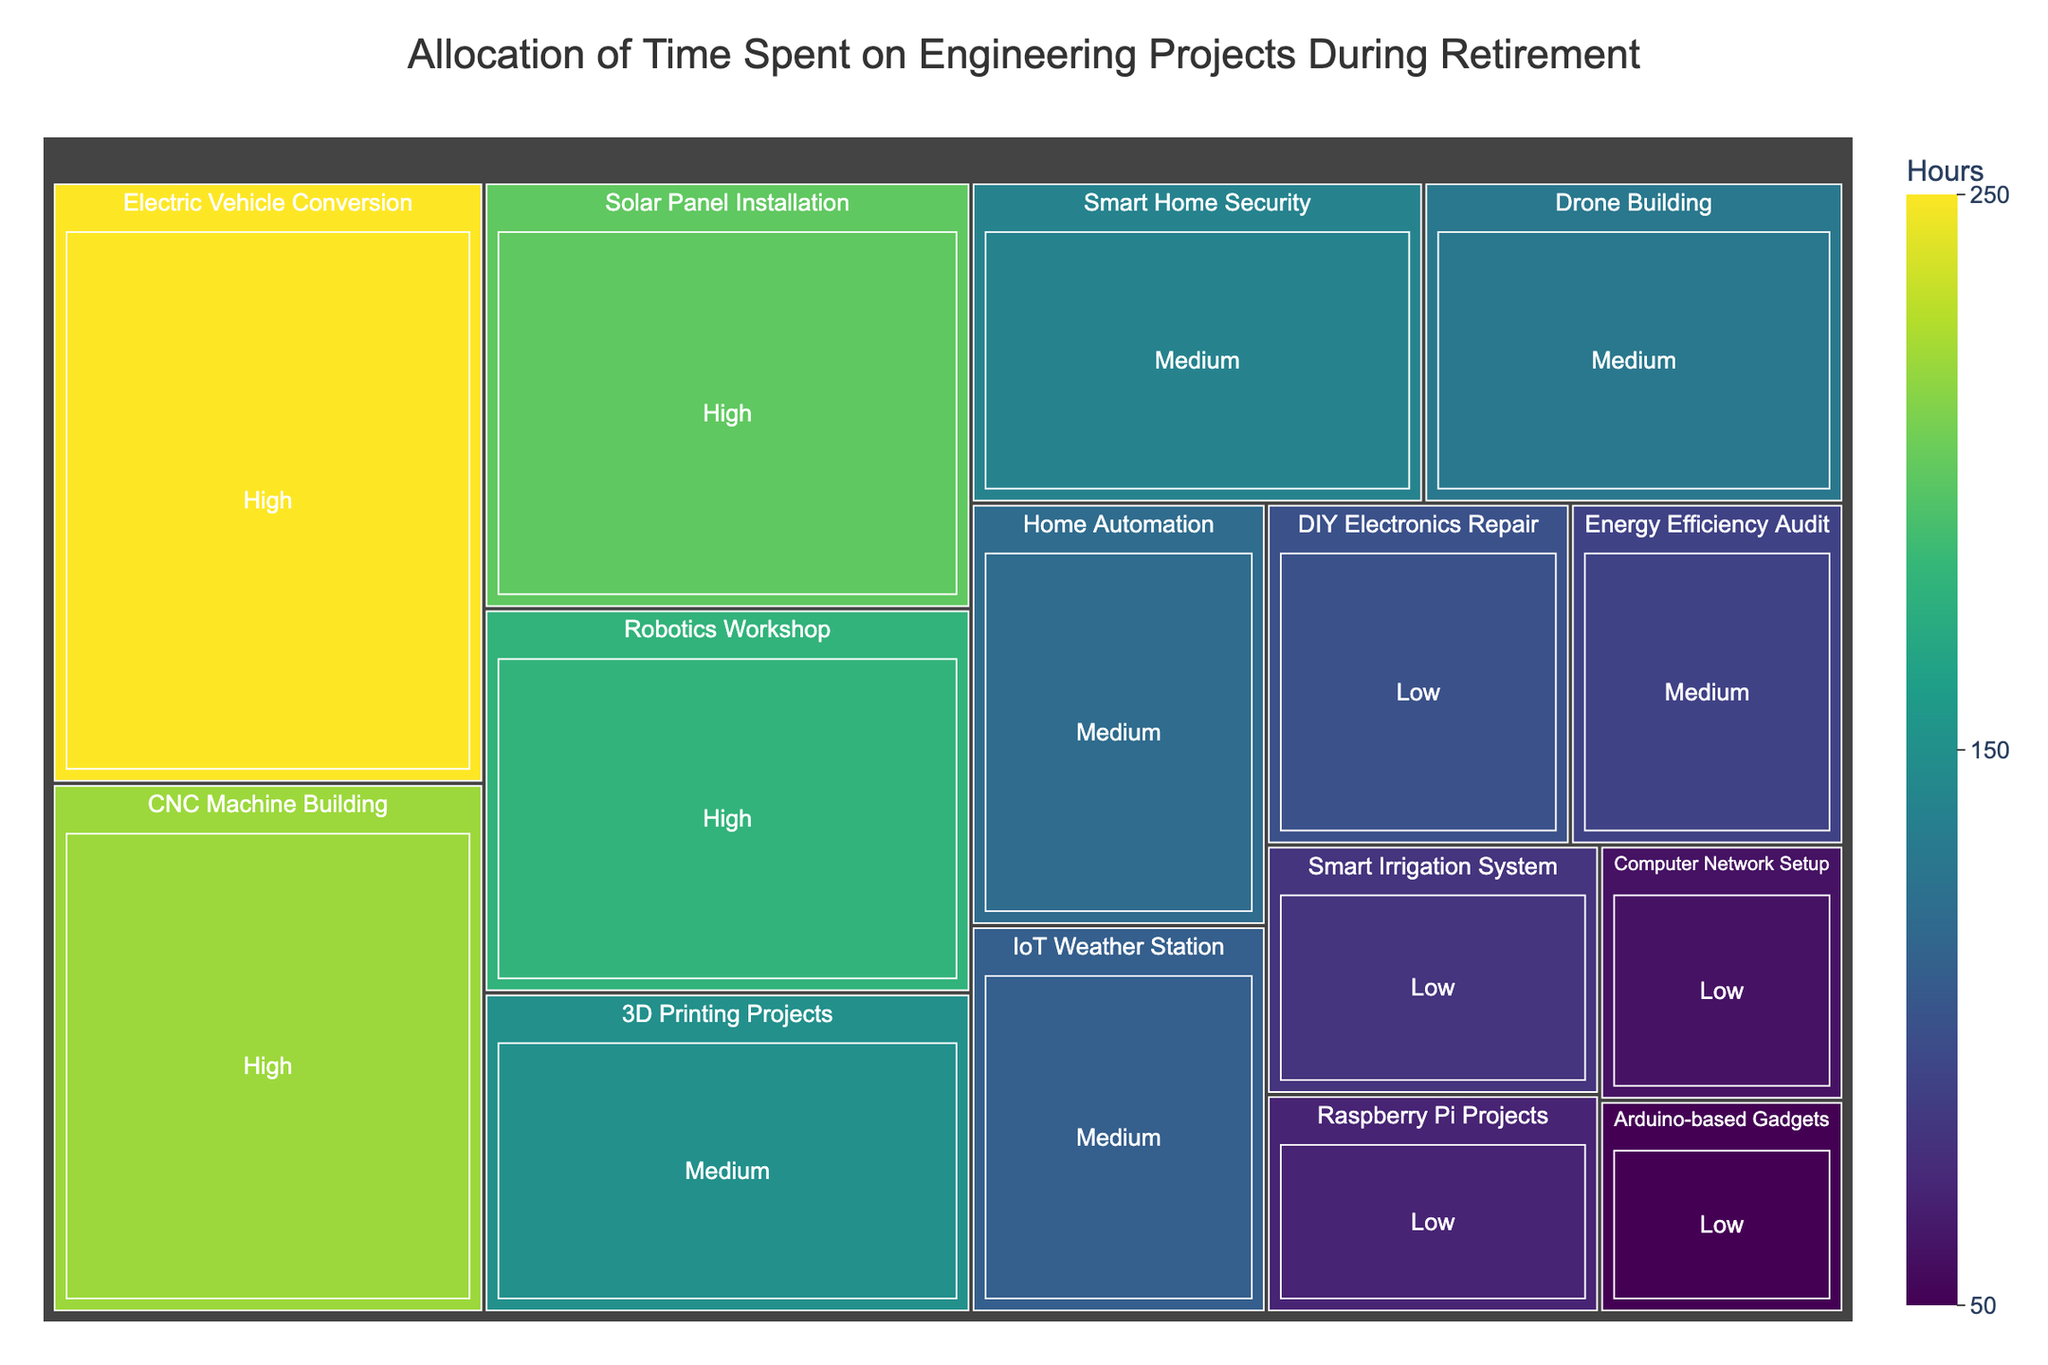What's the title of the figure? The title is placed at the top of the treemap and represents the overall theme of the figure.
Answer: Allocation of Time Spent on Engineering Projects During Retirement How many hours were spent on high complexity projects? To determine the total hours spent on high complexity projects, sum up the hours of all high complexity projects: Solar Panel Installation (200) + Robotics Workshop (180) + Electric Vehicle Conversion (250) + CNC Machine Building (220). 200 + 180 + 250 + 220 = 850
Answer: 850 Which project type had the highest number of hours? Look for the largest segment in the treemap and check its corresponding project type by comparing the hours. Electric Vehicle Conversion has the highest hours at 250.
Answer: Electric Vehicle Conversion What is the difference in hours between the project with the most time spent and the project with the least time spent? Identify the projects with the maximum and minimum hours from the treemap. The project with the most time is Electric Vehicle Conversion (250 hours) and the one with the least time is Arduino-based Gadgets (50 hours). The difference is 250 - 50 = 200 hours.
Answer: 200 How many medium complexity projects are there? Count the number of segments classified under medium complexity in the treemap. These projects include Home Automation, 3D Printing Projects, Energy Efficiency Audit, IoT Weather Station, Drone Building, and Smart Home Security. There are 6 medium complexity projects.
Answer: 6 Which project types had exactly 100 hours spent on them? Find and identify all blocks that indicate exactly 100 hours in the treemap. DIY Electronics Repair is the project type with exactly 100 hours.
Answer: DIY Electronics Repair How does the time spent on medium complexity projects compare to low complexity projects? Sum the hours spent on both medium and low complexity projects:
For medium complexity: Home Automation (120) + 3D Printing Projects (150) + Energy Efficiency Audit (90) + IoT Weather Station (110) + Drone Building (130) + Smart Home Security (140) = 740.
For low complexity: Smart Irrigation System (80) + DIY Electronics Repair (100) + Computer Network Setup (60) + Raspberry Pi Projects (70) + Arduino-based Gadgets (50) = 360.
Medium complexity: 740, Low complexity: 360. Medium complexity projects have more hours.
Answer: Medium complexity has more hours Which shading color indicates higher hours? In the treemap, darker shades or more intense colors typically represent higher values. By observing the color gradient used, the darker shades or more vibrant sections indicate higher hours.
Answer: Darker/Vibrant colors Which project had the closest number of hours to 150? Look at the projects around the 150 mark in the treemap and find the closest one. 3D Printing Projects has 150 hours, which is exactly equal to 150.
Answer: 3D Printing Projects 